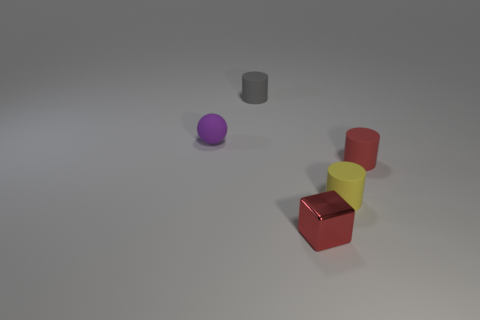Add 5 tiny rubber balls. How many objects exist? 10 Subtract all spheres. How many objects are left? 4 Add 3 brown metallic spheres. How many brown metallic spheres exist? 3 Subtract 0 blue cubes. How many objects are left? 5 Subtract all yellow cylinders. Subtract all tiny yellow objects. How many objects are left? 3 Add 1 small red matte cylinders. How many small red matte cylinders are left? 2 